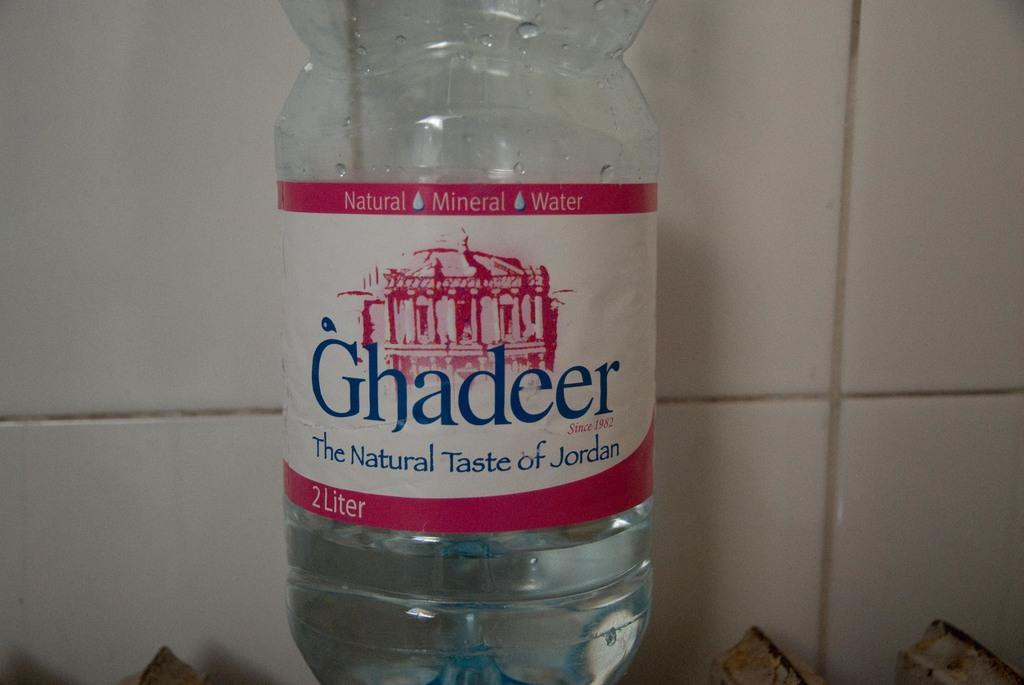<image>
Share a concise interpretation of the image provided. a bottle of ghadeer the natural taste of jordan natural mineral water 